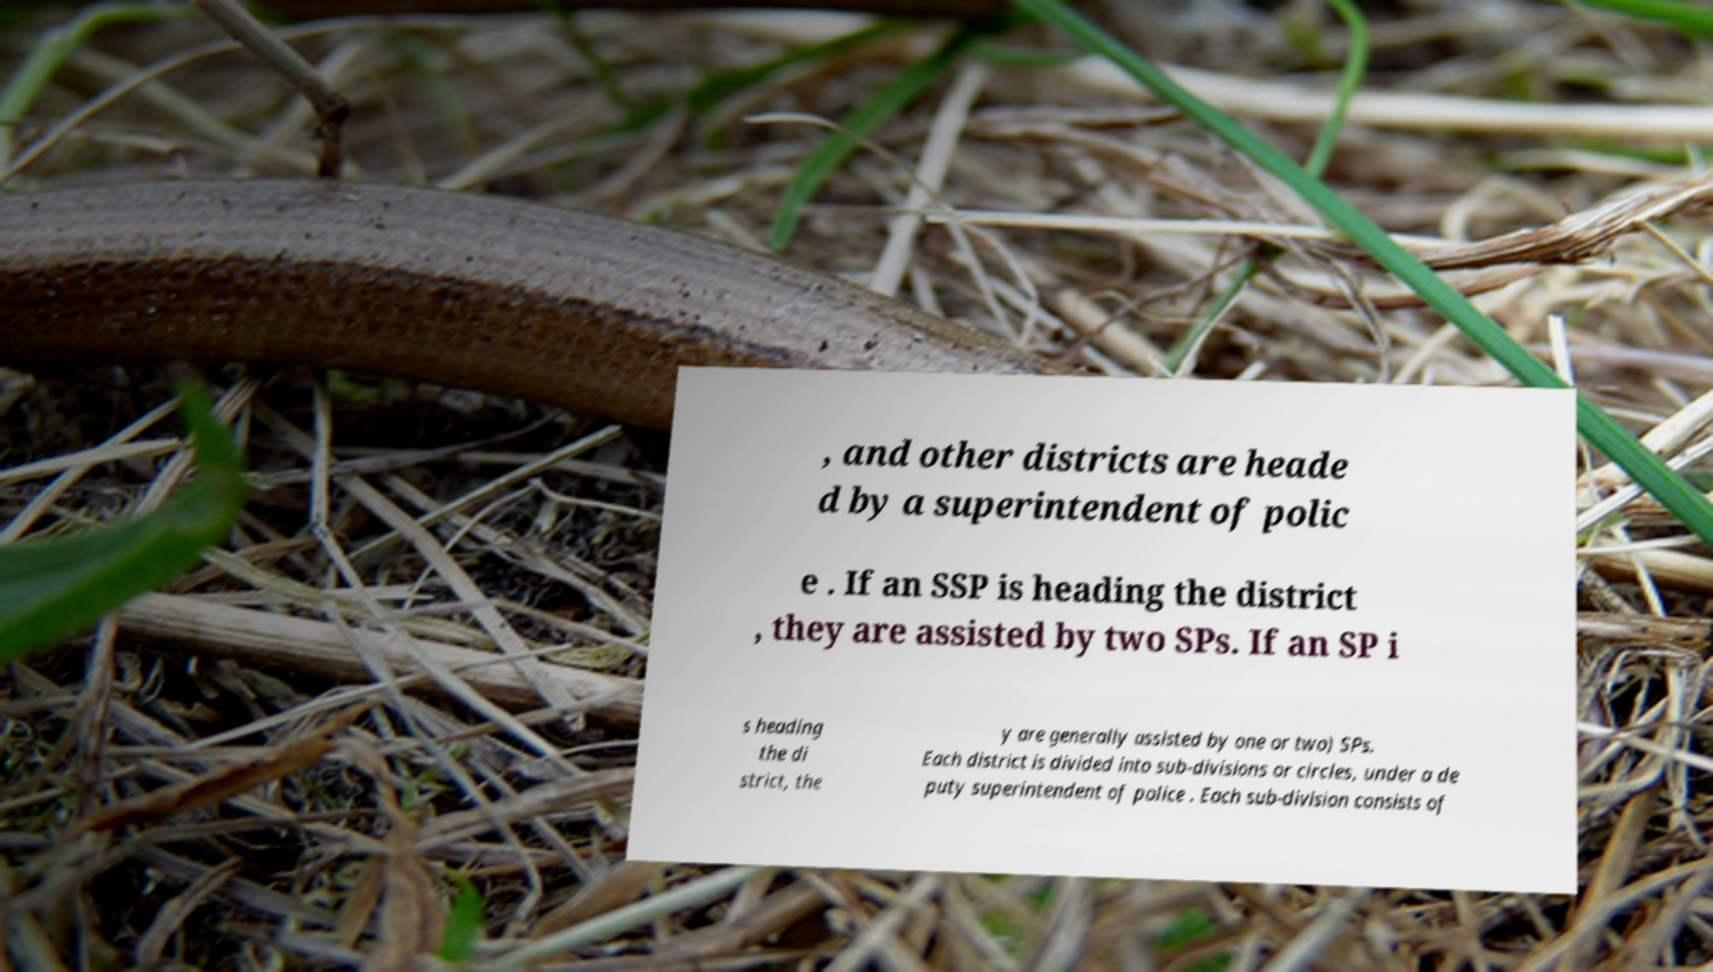What messages or text are displayed in this image? I need them in a readable, typed format. , and other districts are heade d by a superintendent of polic e . If an SSP is heading the district , they are assisted by two SPs. If an SP i s heading the di strict, the y are generally assisted by one or two) SPs. Each district is divided into sub-divisions or circles, under a de puty superintendent of police . Each sub-division consists of 